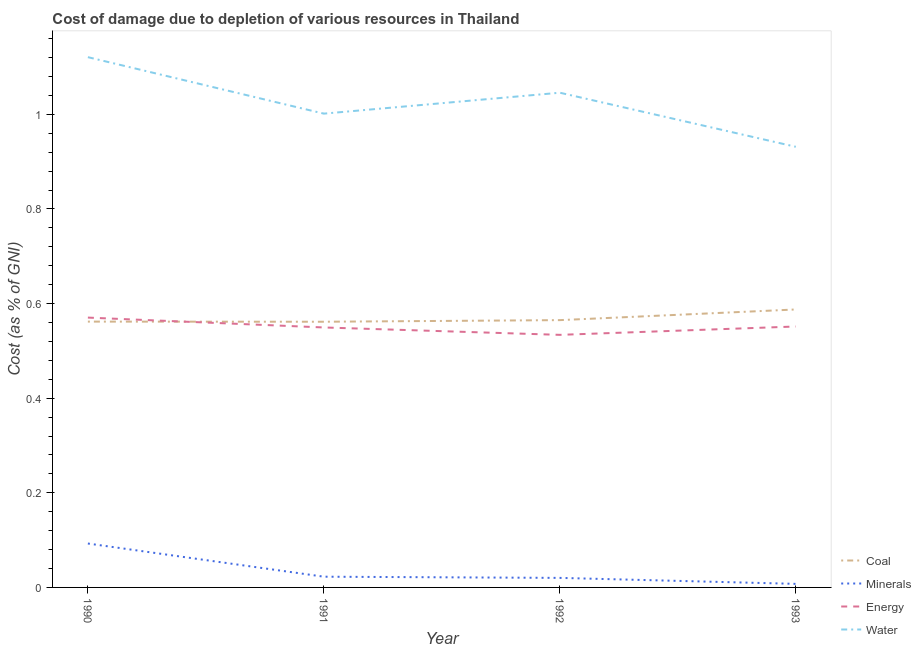How many different coloured lines are there?
Give a very brief answer. 4. Does the line corresponding to cost of damage due to depletion of energy intersect with the line corresponding to cost of damage due to depletion of water?
Ensure brevity in your answer.  No. Is the number of lines equal to the number of legend labels?
Offer a terse response. Yes. What is the cost of damage due to depletion of minerals in 1993?
Your answer should be compact. 0.01. Across all years, what is the maximum cost of damage due to depletion of minerals?
Offer a terse response. 0.09. Across all years, what is the minimum cost of damage due to depletion of water?
Offer a very short reply. 0.93. In which year was the cost of damage due to depletion of energy maximum?
Your answer should be very brief. 1990. What is the total cost of damage due to depletion of minerals in the graph?
Provide a succinct answer. 0.14. What is the difference between the cost of damage due to depletion of energy in 1991 and that in 1992?
Your answer should be very brief. 0.02. What is the difference between the cost of damage due to depletion of coal in 1992 and the cost of damage due to depletion of water in 1990?
Give a very brief answer. -0.56. What is the average cost of damage due to depletion of minerals per year?
Give a very brief answer. 0.04. In the year 1990, what is the difference between the cost of damage due to depletion of energy and cost of damage due to depletion of water?
Your answer should be very brief. -0.55. What is the ratio of the cost of damage due to depletion of coal in 1990 to that in 1992?
Offer a very short reply. 0.99. Is the difference between the cost of damage due to depletion of energy in 1990 and 1991 greater than the difference between the cost of damage due to depletion of minerals in 1990 and 1991?
Provide a succinct answer. No. What is the difference between the highest and the second highest cost of damage due to depletion of water?
Provide a short and direct response. 0.08. What is the difference between the highest and the lowest cost of damage due to depletion of coal?
Your response must be concise. 0.03. In how many years, is the cost of damage due to depletion of water greater than the average cost of damage due to depletion of water taken over all years?
Provide a short and direct response. 2. Is the sum of the cost of damage due to depletion of coal in 1991 and 1993 greater than the maximum cost of damage due to depletion of energy across all years?
Your response must be concise. Yes. Is it the case that in every year, the sum of the cost of damage due to depletion of water and cost of damage due to depletion of energy is greater than the sum of cost of damage due to depletion of coal and cost of damage due to depletion of minerals?
Your response must be concise. Yes. How many lines are there?
Your answer should be very brief. 4. How many years are there in the graph?
Provide a succinct answer. 4. What is the difference between two consecutive major ticks on the Y-axis?
Make the answer very short. 0.2. Are the values on the major ticks of Y-axis written in scientific E-notation?
Keep it short and to the point. No. Does the graph contain any zero values?
Provide a short and direct response. No. Where does the legend appear in the graph?
Your answer should be compact. Bottom right. What is the title of the graph?
Make the answer very short. Cost of damage due to depletion of various resources in Thailand . What is the label or title of the X-axis?
Your response must be concise. Year. What is the label or title of the Y-axis?
Make the answer very short. Cost (as % of GNI). What is the Cost (as % of GNI) of Coal in 1990?
Provide a succinct answer. 0.56. What is the Cost (as % of GNI) in Minerals in 1990?
Ensure brevity in your answer.  0.09. What is the Cost (as % of GNI) in Energy in 1990?
Offer a terse response. 0.57. What is the Cost (as % of GNI) in Water in 1990?
Your answer should be compact. 1.12. What is the Cost (as % of GNI) in Coal in 1991?
Provide a short and direct response. 0.56. What is the Cost (as % of GNI) in Minerals in 1991?
Provide a short and direct response. 0.02. What is the Cost (as % of GNI) of Energy in 1991?
Your response must be concise. 0.55. What is the Cost (as % of GNI) of Water in 1991?
Give a very brief answer. 1. What is the Cost (as % of GNI) of Coal in 1992?
Your answer should be compact. 0.57. What is the Cost (as % of GNI) in Minerals in 1992?
Offer a terse response. 0.02. What is the Cost (as % of GNI) of Energy in 1992?
Ensure brevity in your answer.  0.53. What is the Cost (as % of GNI) in Water in 1992?
Keep it short and to the point. 1.05. What is the Cost (as % of GNI) of Coal in 1993?
Your response must be concise. 0.59. What is the Cost (as % of GNI) in Minerals in 1993?
Provide a short and direct response. 0.01. What is the Cost (as % of GNI) of Energy in 1993?
Offer a very short reply. 0.55. What is the Cost (as % of GNI) of Water in 1993?
Offer a very short reply. 0.93. Across all years, what is the maximum Cost (as % of GNI) in Coal?
Offer a very short reply. 0.59. Across all years, what is the maximum Cost (as % of GNI) in Minerals?
Ensure brevity in your answer.  0.09. Across all years, what is the maximum Cost (as % of GNI) of Energy?
Your answer should be very brief. 0.57. Across all years, what is the maximum Cost (as % of GNI) in Water?
Provide a short and direct response. 1.12. Across all years, what is the minimum Cost (as % of GNI) in Coal?
Provide a succinct answer. 0.56. Across all years, what is the minimum Cost (as % of GNI) of Minerals?
Offer a terse response. 0.01. Across all years, what is the minimum Cost (as % of GNI) in Energy?
Ensure brevity in your answer.  0.53. Across all years, what is the minimum Cost (as % of GNI) of Water?
Ensure brevity in your answer.  0.93. What is the total Cost (as % of GNI) in Coal in the graph?
Ensure brevity in your answer.  2.28. What is the total Cost (as % of GNI) in Minerals in the graph?
Offer a very short reply. 0.14. What is the total Cost (as % of GNI) of Energy in the graph?
Provide a succinct answer. 2.21. What is the total Cost (as % of GNI) in Water in the graph?
Your response must be concise. 4.1. What is the difference between the Cost (as % of GNI) in Minerals in 1990 and that in 1991?
Keep it short and to the point. 0.07. What is the difference between the Cost (as % of GNI) of Energy in 1990 and that in 1991?
Your response must be concise. 0.02. What is the difference between the Cost (as % of GNI) in Water in 1990 and that in 1991?
Provide a succinct answer. 0.12. What is the difference between the Cost (as % of GNI) in Coal in 1990 and that in 1992?
Offer a terse response. -0. What is the difference between the Cost (as % of GNI) in Minerals in 1990 and that in 1992?
Your answer should be very brief. 0.07. What is the difference between the Cost (as % of GNI) in Energy in 1990 and that in 1992?
Provide a short and direct response. 0.04. What is the difference between the Cost (as % of GNI) of Water in 1990 and that in 1992?
Keep it short and to the point. 0.08. What is the difference between the Cost (as % of GNI) of Coal in 1990 and that in 1993?
Provide a succinct answer. -0.03. What is the difference between the Cost (as % of GNI) in Minerals in 1990 and that in 1993?
Provide a short and direct response. 0.09. What is the difference between the Cost (as % of GNI) in Energy in 1990 and that in 1993?
Keep it short and to the point. 0.02. What is the difference between the Cost (as % of GNI) of Water in 1990 and that in 1993?
Provide a succinct answer. 0.19. What is the difference between the Cost (as % of GNI) in Coal in 1991 and that in 1992?
Your response must be concise. -0. What is the difference between the Cost (as % of GNI) in Minerals in 1991 and that in 1992?
Make the answer very short. 0. What is the difference between the Cost (as % of GNI) in Energy in 1991 and that in 1992?
Keep it short and to the point. 0.02. What is the difference between the Cost (as % of GNI) in Water in 1991 and that in 1992?
Your response must be concise. -0.04. What is the difference between the Cost (as % of GNI) of Coal in 1991 and that in 1993?
Offer a terse response. -0.03. What is the difference between the Cost (as % of GNI) in Minerals in 1991 and that in 1993?
Make the answer very short. 0.02. What is the difference between the Cost (as % of GNI) of Energy in 1991 and that in 1993?
Your answer should be very brief. -0. What is the difference between the Cost (as % of GNI) in Water in 1991 and that in 1993?
Provide a short and direct response. 0.07. What is the difference between the Cost (as % of GNI) in Coal in 1992 and that in 1993?
Give a very brief answer. -0.02. What is the difference between the Cost (as % of GNI) in Minerals in 1992 and that in 1993?
Offer a terse response. 0.01. What is the difference between the Cost (as % of GNI) of Energy in 1992 and that in 1993?
Make the answer very short. -0.02. What is the difference between the Cost (as % of GNI) of Water in 1992 and that in 1993?
Make the answer very short. 0.11. What is the difference between the Cost (as % of GNI) of Coal in 1990 and the Cost (as % of GNI) of Minerals in 1991?
Your answer should be compact. 0.54. What is the difference between the Cost (as % of GNI) in Coal in 1990 and the Cost (as % of GNI) in Energy in 1991?
Keep it short and to the point. 0.01. What is the difference between the Cost (as % of GNI) of Coal in 1990 and the Cost (as % of GNI) of Water in 1991?
Provide a short and direct response. -0.44. What is the difference between the Cost (as % of GNI) in Minerals in 1990 and the Cost (as % of GNI) in Energy in 1991?
Offer a very short reply. -0.46. What is the difference between the Cost (as % of GNI) in Minerals in 1990 and the Cost (as % of GNI) in Water in 1991?
Offer a terse response. -0.91. What is the difference between the Cost (as % of GNI) of Energy in 1990 and the Cost (as % of GNI) of Water in 1991?
Offer a terse response. -0.43. What is the difference between the Cost (as % of GNI) in Coal in 1990 and the Cost (as % of GNI) in Minerals in 1992?
Your response must be concise. 0.54. What is the difference between the Cost (as % of GNI) of Coal in 1990 and the Cost (as % of GNI) of Energy in 1992?
Provide a succinct answer. 0.03. What is the difference between the Cost (as % of GNI) in Coal in 1990 and the Cost (as % of GNI) in Water in 1992?
Your answer should be very brief. -0.48. What is the difference between the Cost (as % of GNI) of Minerals in 1990 and the Cost (as % of GNI) of Energy in 1992?
Provide a succinct answer. -0.44. What is the difference between the Cost (as % of GNI) of Minerals in 1990 and the Cost (as % of GNI) of Water in 1992?
Keep it short and to the point. -0.95. What is the difference between the Cost (as % of GNI) in Energy in 1990 and the Cost (as % of GNI) in Water in 1992?
Provide a succinct answer. -0.48. What is the difference between the Cost (as % of GNI) of Coal in 1990 and the Cost (as % of GNI) of Minerals in 1993?
Your answer should be very brief. 0.55. What is the difference between the Cost (as % of GNI) in Coal in 1990 and the Cost (as % of GNI) in Energy in 1993?
Provide a succinct answer. 0.01. What is the difference between the Cost (as % of GNI) in Coal in 1990 and the Cost (as % of GNI) in Water in 1993?
Offer a terse response. -0.37. What is the difference between the Cost (as % of GNI) in Minerals in 1990 and the Cost (as % of GNI) in Energy in 1993?
Give a very brief answer. -0.46. What is the difference between the Cost (as % of GNI) in Minerals in 1990 and the Cost (as % of GNI) in Water in 1993?
Provide a short and direct response. -0.84. What is the difference between the Cost (as % of GNI) of Energy in 1990 and the Cost (as % of GNI) of Water in 1993?
Your response must be concise. -0.36. What is the difference between the Cost (as % of GNI) of Coal in 1991 and the Cost (as % of GNI) of Minerals in 1992?
Offer a very short reply. 0.54. What is the difference between the Cost (as % of GNI) in Coal in 1991 and the Cost (as % of GNI) in Energy in 1992?
Make the answer very short. 0.03. What is the difference between the Cost (as % of GNI) of Coal in 1991 and the Cost (as % of GNI) of Water in 1992?
Provide a short and direct response. -0.48. What is the difference between the Cost (as % of GNI) in Minerals in 1991 and the Cost (as % of GNI) in Energy in 1992?
Provide a succinct answer. -0.51. What is the difference between the Cost (as % of GNI) in Minerals in 1991 and the Cost (as % of GNI) in Water in 1992?
Make the answer very short. -1.02. What is the difference between the Cost (as % of GNI) in Energy in 1991 and the Cost (as % of GNI) in Water in 1992?
Offer a very short reply. -0.5. What is the difference between the Cost (as % of GNI) of Coal in 1991 and the Cost (as % of GNI) of Minerals in 1993?
Your answer should be compact. 0.55. What is the difference between the Cost (as % of GNI) of Coal in 1991 and the Cost (as % of GNI) of Energy in 1993?
Provide a succinct answer. 0.01. What is the difference between the Cost (as % of GNI) of Coal in 1991 and the Cost (as % of GNI) of Water in 1993?
Keep it short and to the point. -0.37. What is the difference between the Cost (as % of GNI) of Minerals in 1991 and the Cost (as % of GNI) of Energy in 1993?
Ensure brevity in your answer.  -0.53. What is the difference between the Cost (as % of GNI) in Minerals in 1991 and the Cost (as % of GNI) in Water in 1993?
Provide a succinct answer. -0.91. What is the difference between the Cost (as % of GNI) of Energy in 1991 and the Cost (as % of GNI) of Water in 1993?
Give a very brief answer. -0.38. What is the difference between the Cost (as % of GNI) in Coal in 1992 and the Cost (as % of GNI) in Minerals in 1993?
Offer a very short reply. 0.56. What is the difference between the Cost (as % of GNI) of Coal in 1992 and the Cost (as % of GNI) of Energy in 1993?
Your response must be concise. 0.01. What is the difference between the Cost (as % of GNI) in Coal in 1992 and the Cost (as % of GNI) in Water in 1993?
Ensure brevity in your answer.  -0.37. What is the difference between the Cost (as % of GNI) of Minerals in 1992 and the Cost (as % of GNI) of Energy in 1993?
Give a very brief answer. -0.53. What is the difference between the Cost (as % of GNI) in Minerals in 1992 and the Cost (as % of GNI) in Water in 1993?
Your response must be concise. -0.91. What is the difference between the Cost (as % of GNI) in Energy in 1992 and the Cost (as % of GNI) in Water in 1993?
Offer a very short reply. -0.4. What is the average Cost (as % of GNI) of Coal per year?
Provide a succinct answer. 0.57. What is the average Cost (as % of GNI) of Minerals per year?
Offer a very short reply. 0.04. What is the average Cost (as % of GNI) in Energy per year?
Your response must be concise. 0.55. In the year 1990, what is the difference between the Cost (as % of GNI) in Coal and Cost (as % of GNI) in Minerals?
Your response must be concise. 0.47. In the year 1990, what is the difference between the Cost (as % of GNI) of Coal and Cost (as % of GNI) of Energy?
Provide a short and direct response. -0.01. In the year 1990, what is the difference between the Cost (as % of GNI) in Coal and Cost (as % of GNI) in Water?
Make the answer very short. -0.56. In the year 1990, what is the difference between the Cost (as % of GNI) in Minerals and Cost (as % of GNI) in Energy?
Provide a succinct answer. -0.48. In the year 1990, what is the difference between the Cost (as % of GNI) of Minerals and Cost (as % of GNI) of Water?
Your answer should be compact. -1.03. In the year 1990, what is the difference between the Cost (as % of GNI) of Energy and Cost (as % of GNI) of Water?
Make the answer very short. -0.55. In the year 1991, what is the difference between the Cost (as % of GNI) in Coal and Cost (as % of GNI) in Minerals?
Your response must be concise. 0.54. In the year 1991, what is the difference between the Cost (as % of GNI) of Coal and Cost (as % of GNI) of Energy?
Provide a short and direct response. 0.01. In the year 1991, what is the difference between the Cost (as % of GNI) in Coal and Cost (as % of GNI) in Water?
Give a very brief answer. -0.44. In the year 1991, what is the difference between the Cost (as % of GNI) of Minerals and Cost (as % of GNI) of Energy?
Give a very brief answer. -0.53. In the year 1991, what is the difference between the Cost (as % of GNI) in Minerals and Cost (as % of GNI) in Water?
Offer a terse response. -0.98. In the year 1991, what is the difference between the Cost (as % of GNI) in Energy and Cost (as % of GNI) in Water?
Offer a very short reply. -0.45. In the year 1992, what is the difference between the Cost (as % of GNI) in Coal and Cost (as % of GNI) in Minerals?
Keep it short and to the point. 0.54. In the year 1992, what is the difference between the Cost (as % of GNI) of Coal and Cost (as % of GNI) of Energy?
Offer a terse response. 0.03. In the year 1992, what is the difference between the Cost (as % of GNI) in Coal and Cost (as % of GNI) in Water?
Your answer should be very brief. -0.48. In the year 1992, what is the difference between the Cost (as % of GNI) in Minerals and Cost (as % of GNI) in Energy?
Your response must be concise. -0.51. In the year 1992, what is the difference between the Cost (as % of GNI) of Minerals and Cost (as % of GNI) of Water?
Keep it short and to the point. -1.03. In the year 1992, what is the difference between the Cost (as % of GNI) of Energy and Cost (as % of GNI) of Water?
Your response must be concise. -0.51. In the year 1993, what is the difference between the Cost (as % of GNI) in Coal and Cost (as % of GNI) in Minerals?
Keep it short and to the point. 0.58. In the year 1993, what is the difference between the Cost (as % of GNI) in Coal and Cost (as % of GNI) in Energy?
Your response must be concise. 0.04. In the year 1993, what is the difference between the Cost (as % of GNI) of Coal and Cost (as % of GNI) of Water?
Provide a short and direct response. -0.34. In the year 1993, what is the difference between the Cost (as % of GNI) in Minerals and Cost (as % of GNI) in Energy?
Your response must be concise. -0.54. In the year 1993, what is the difference between the Cost (as % of GNI) in Minerals and Cost (as % of GNI) in Water?
Provide a short and direct response. -0.92. In the year 1993, what is the difference between the Cost (as % of GNI) in Energy and Cost (as % of GNI) in Water?
Make the answer very short. -0.38. What is the ratio of the Cost (as % of GNI) of Coal in 1990 to that in 1991?
Offer a terse response. 1. What is the ratio of the Cost (as % of GNI) of Minerals in 1990 to that in 1991?
Keep it short and to the point. 4.09. What is the ratio of the Cost (as % of GNI) in Energy in 1990 to that in 1991?
Your answer should be very brief. 1.04. What is the ratio of the Cost (as % of GNI) of Water in 1990 to that in 1991?
Make the answer very short. 1.12. What is the ratio of the Cost (as % of GNI) of Minerals in 1990 to that in 1992?
Offer a very short reply. 4.6. What is the ratio of the Cost (as % of GNI) of Energy in 1990 to that in 1992?
Offer a very short reply. 1.07. What is the ratio of the Cost (as % of GNI) of Water in 1990 to that in 1992?
Your response must be concise. 1.07. What is the ratio of the Cost (as % of GNI) of Coal in 1990 to that in 1993?
Give a very brief answer. 0.96. What is the ratio of the Cost (as % of GNI) in Minerals in 1990 to that in 1993?
Your answer should be compact. 12.33. What is the ratio of the Cost (as % of GNI) in Energy in 1990 to that in 1993?
Your answer should be very brief. 1.03. What is the ratio of the Cost (as % of GNI) of Water in 1990 to that in 1993?
Ensure brevity in your answer.  1.2. What is the ratio of the Cost (as % of GNI) of Coal in 1991 to that in 1992?
Offer a very short reply. 0.99. What is the ratio of the Cost (as % of GNI) in Minerals in 1991 to that in 1992?
Your answer should be compact. 1.12. What is the ratio of the Cost (as % of GNI) of Energy in 1991 to that in 1992?
Make the answer very short. 1.03. What is the ratio of the Cost (as % of GNI) of Water in 1991 to that in 1992?
Offer a terse response. 0.96. What is the ratio of the Cost (as % of GNI) in Coal in 1991 to that in 1993?
Your answer should be compact. 0.96. What is the ratio of the Cost (as % of GNI) of Minerals in 1991 to that in 1993?
Make the answer very short. 3.01. What is the ratio of the Cost (as % of GNI) in Energy in 1991 to that in 1993?
Give a very brief answer. 1. What is the ratio of the Cost (as % of GNI) of Water in 1991 to that in 1993?
Ensure brevity in your answer.  1.08. What is the ratio of the Cost (as % of GNI) in Coal in 1992 to that in 1993?
Provide a short and direct response. 0.96. What is the ratio of the Cost (as % of GNI) of Minerals in 1992 to that in 1993?
Your answer should be compact. 2.68. What is the ratio of the Cost (as % of GNI) of Water in 1992 to that in 1993?
Make the answer very short. 1.12. What is the difference between the highest and the second highest Cost (as % of GNI) of Coal?
Provide a succinct answer. 0.02. What is the difference between the highest and the second highest Cost (as % of GNI) in Minerals?
Your response must be concise. 0.07. What is the difference between the highest and the second highest Cost (as % of GNI) in Energy?
Your answer should be compact. 0.02. What is the difference between the highest and the second highest Cost (as % of GNI) in Water?
Provide a succinct answer. 0.08. What is the difference between the highest and the lowest Cost (as % of GNI) of Coal?
Your answer should be very brief. 0.03. What is the difference between the highest and the lowest Cost (as % of GNI) in Minerals?
Provide a short and direct response. 0.09. What is the difference between the highest and the lowest Cost (as % of GNI) of Energy?
Provide a short and direct response. 0.04. What is the difference between the highest and the lowest Cost (as % of GNI) in Water?
Provide a succinct answer. 0.19. 